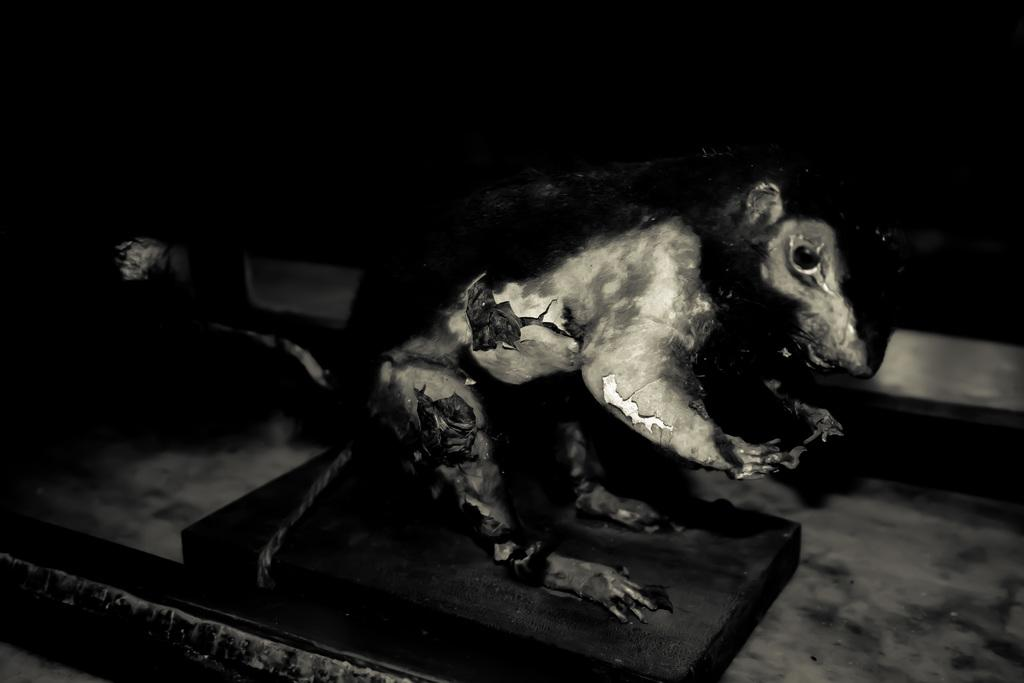What is the color scheme of the image? The image is black and white. What can be seen in the image besides the black and white color scheme? There is a sculpture of an animal in the image. Where is the sculpture located? The sculpture is on a platform. What is the background of the image like? The background of the image is dark. What type of arch can be seen in the background of the image? There is no arch present in the background of the image. What kind of battle is depicted in the image? There is no battle depicted in the image; it features a sculpture of an animal on a platform. 